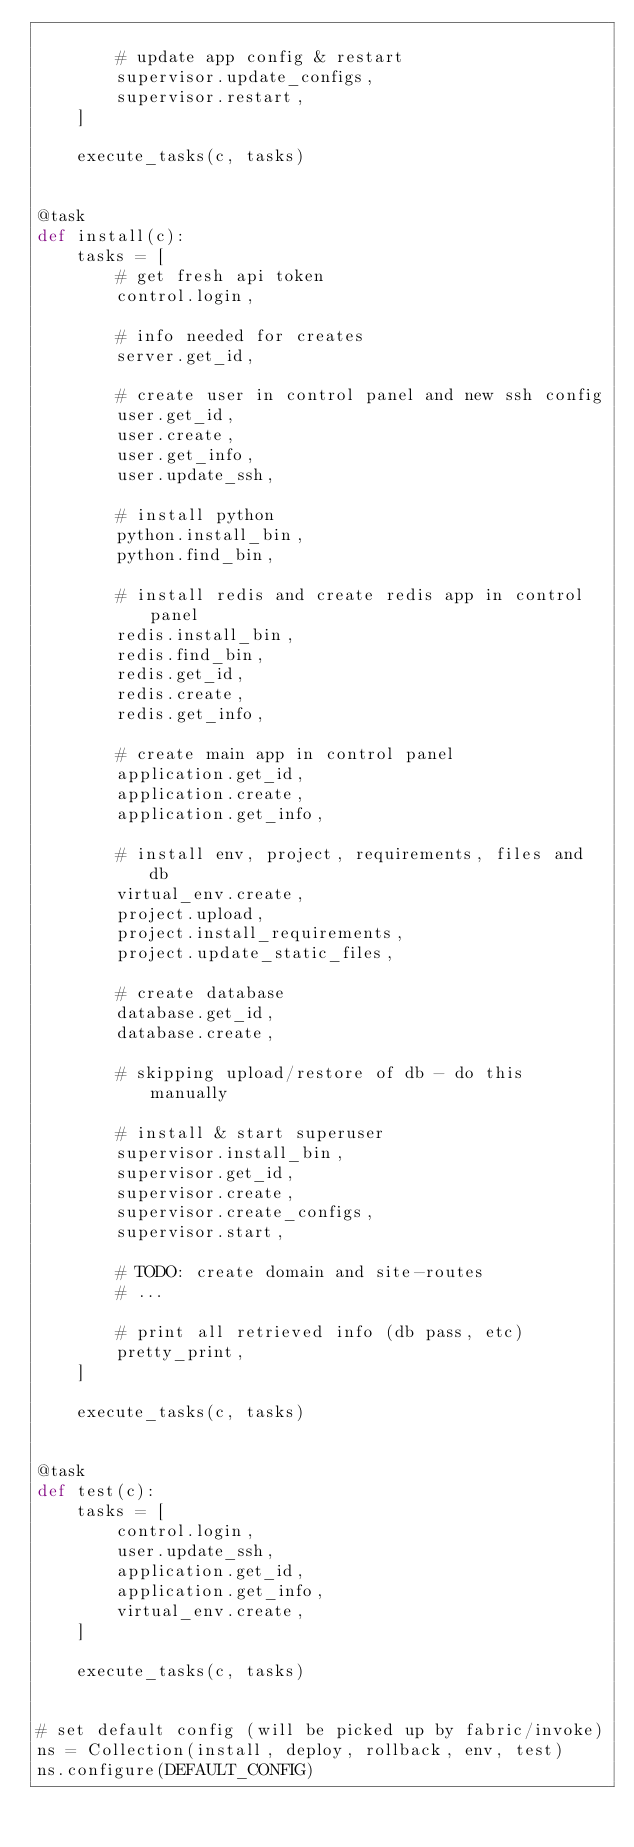Convert code to text. <code><loc_0><loc_0><loc_500><loc_500><_Python_>
        # update app config & restart
        supervisor.update_configs,
        supervisor.restart,
    ]

    execute_tasks(c, tasks)


@task
def install(c):
    tasks = [
        # get fresh api token
        control.login,

        # info needed for creates
        server.get_id,

        # create user in control panel and new ssh config
        user.get_id,
        user.create,
        user.get_info,
        user.update_ssh,

        # install python
        python.install_bin,
        python.find_bin,

        # install redis and create redis app in control panel
        redis.install_bin,
        redis.find_bin,
        redis.get_id,
        redis.create,
        redis.get_info,

        # create main app in control panel
        application.get_id,
        application.create,
        application.get_info,

        # install env, project, requirements, files and db
        virtual_env.create,
        project.upload,
        project.install_requirements,
        project.update_static_files,

        # create database
        database.get_id,
        database.create,

        # skipping upload/restore of db - do this manually

        # install & start superuser
        supervisor.install_bin,
        supervisor.get_id,
        supervisor.create,
        supervisor.create_configs,
        supervisor.start,

        # TODO: create domain and site-routes
        # ...

        # print all retrieved info (db pass, etc)
        pretty_print,
    ]

    execute_tasks(c, tasks)


@task
def test(c):
    tasks = [
        control.login,
        user.update_ssh,
        application.get_id,
        application.get_info,
        virtual_env.create,
    ]

    execute_tasks(c, tasks)


# set default config (will be picked up by fabric/invoke)
ns = Collection(install, deploy, rollback, env, test)
ns.configure(DEFAULT_CONFIG)
</code> 